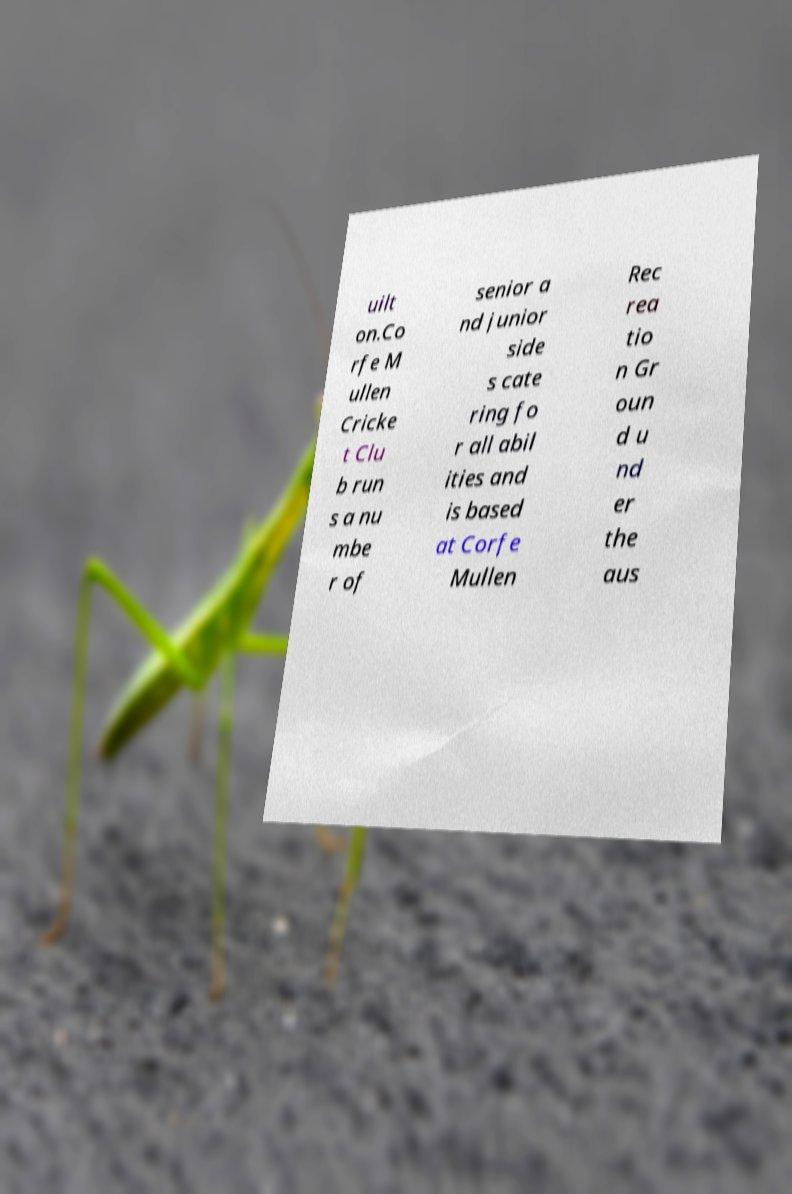Please identify and transcribe the text found in this image. uilt on.Co rfe M ullen Cricke t Clu b run s a nu mbe r of senior a nd junior side s cate ring fo r all abil ities and is based at Corfe Mullen Rec rea tio n Gr oun d u nd er the aus 